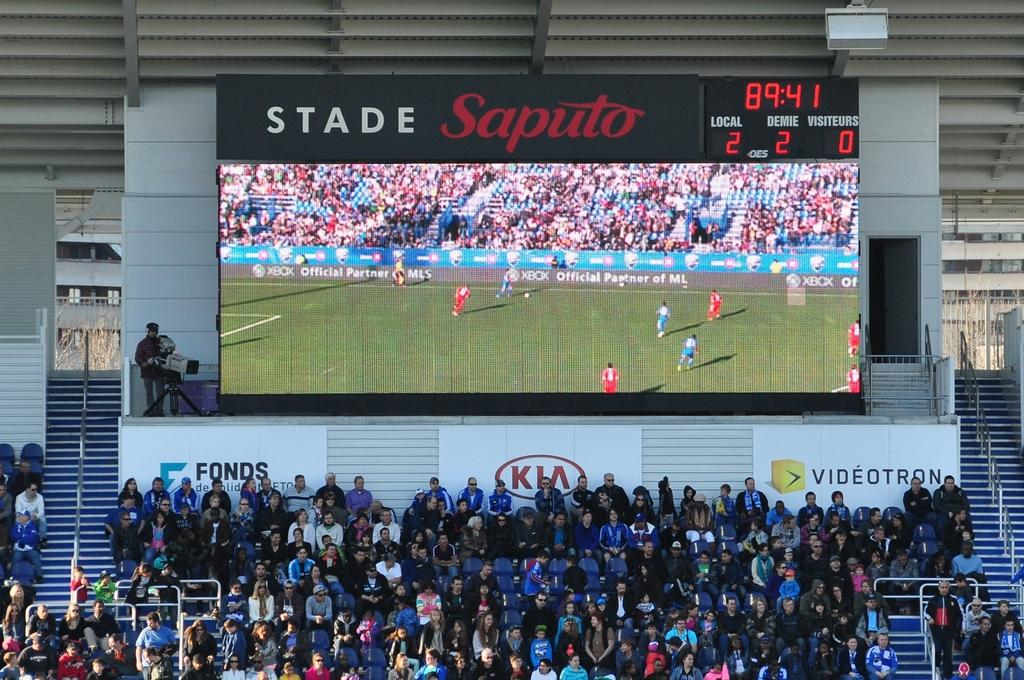<image>
Write a terse but informative summary of the picture. Scoreboard which says stade Saputo above the audience. 